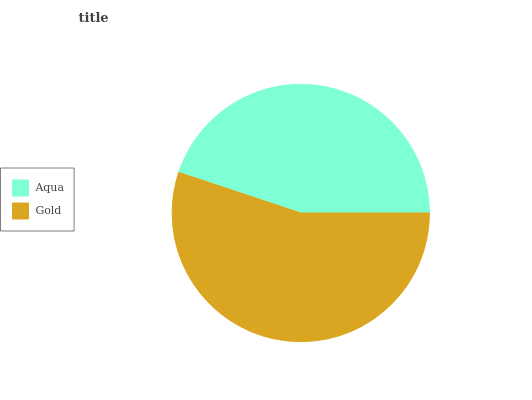Is Aqua the minimum?
Answer yes or no. Yes. Is Gold the maximum?
Answer yes or no. Yes. Is Gold the minimum?
Answer yes or no. No. Is Gold greater than Aqua?
Answer yes or no. Yes. Is Aqua less than Gold?
Answer yes or no. Yes. Is Aqua greater than Gold?
Answer yes or no. No. Is Gold less than Aqua?
Answer yes or no. No. Is Gold the high median?
Answer yes or no. Yes. Is Aqua the low median?
Answer yes or no. Yes. Is Aqua the high median?
Answer yes or no. No. Is Gold the low median?
Answer yes or no. No. 